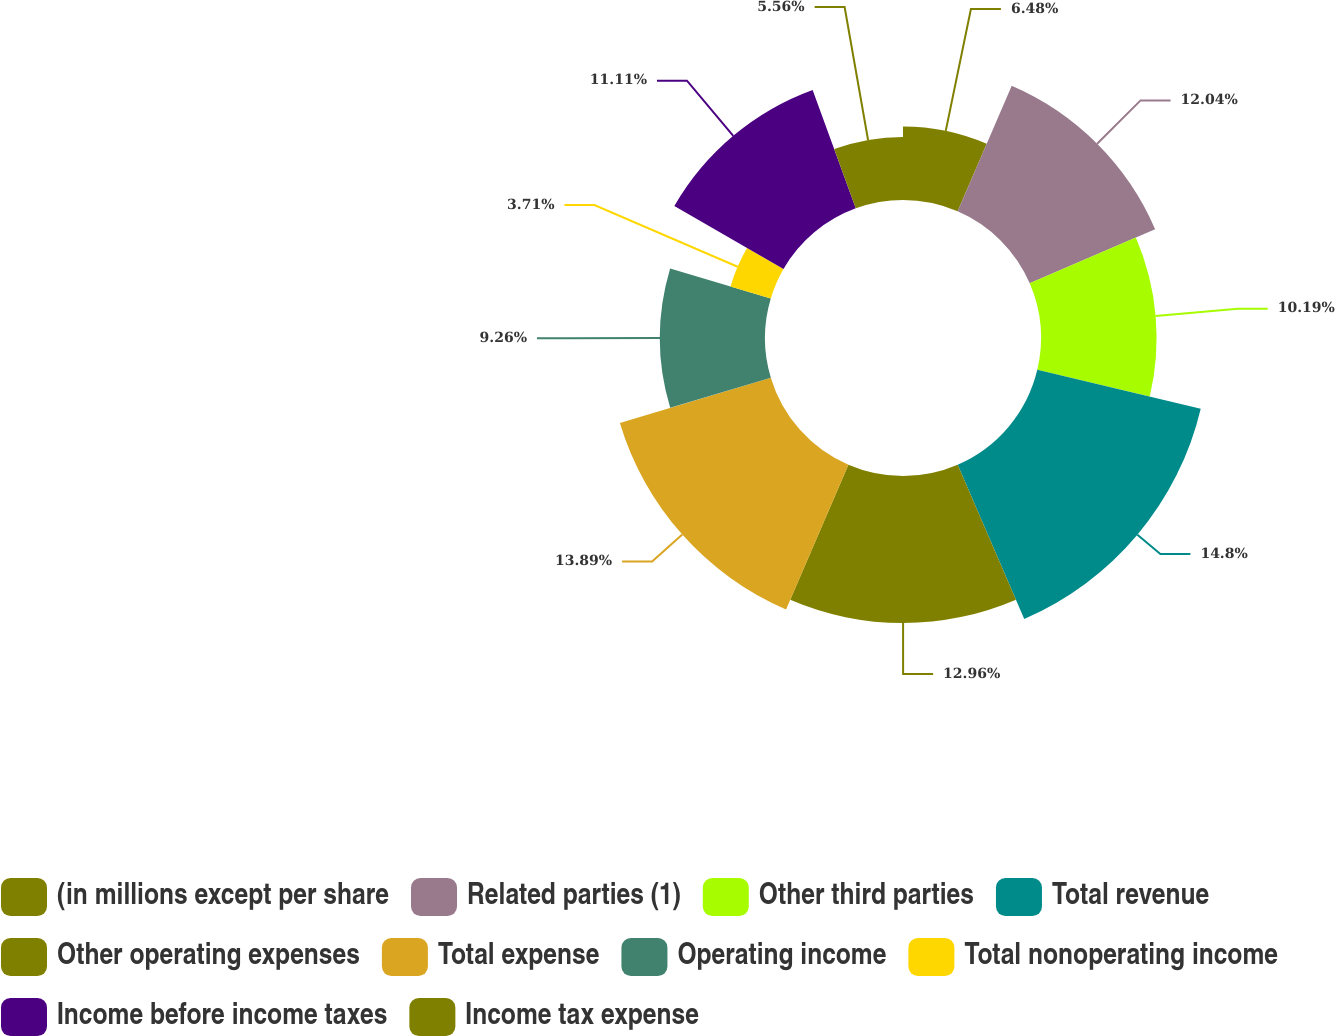<chart> <loc_0><loc_0><loc_500><loc_500><pie_chart><fcel>(in millions except per share<fcel>Related parties (1)<fcel>Other third parties<fcel>Total revenue<fcel>Other operating expenses<fcel>Total expense<fcel>Operating income<fcel>Total nonoperating income<fcel>Income before income taxes<fcel>Income tax expense<nl><fcel>6.48%<fcel>12.04%<fcel>10.19%<fcel>14.81%<fcel>12.96%<fcel>13.89%<fcel>9.26%<fcel>3.71%<fcel>11.11%<fcel>5.56%<nl></chart> 